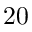Convert formula to latex. <formula><loc_0><loc_0><loc_500><loc_500>2 0</formula> 